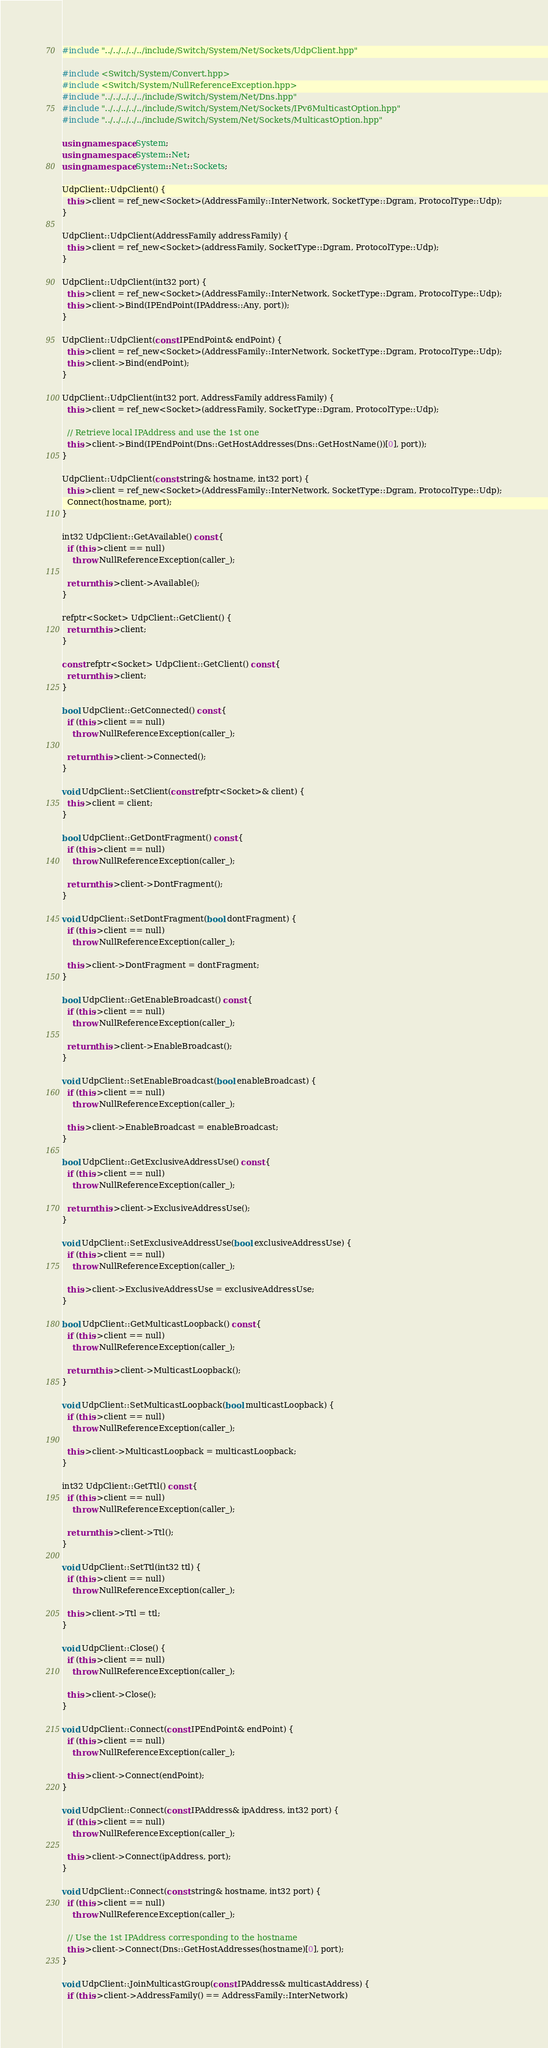Convert code to text. <code><loc_0><loc_0><loc_500><loc_500><_C++_>#include "../../../../../include/Switch/System/Net/Sockets/UdpClient.hpp"

#include <Switch/System/Convert.hpp>
#include <Switch/System/NullReferenceException.hpp>
#include "../../../../../include/Switch/System/Net/Dns.hpp"
#include "../../../../../include/Switch/System/Net/Sockets/IPv6MulticastOption.hpp"
#include "../../../../../include/Switch/System/Net/Sockets/MulticastOption.hpp"

using namespace System;
using namespace System::Net;
using namespace System::Net::Sockets;

UdpClient::UdpClient() {
  this->client = ref_new<Socket>(AddressFamily::InterNetwork, SocketType::Dgram, ProtocolType::Udp);
}

UdpClient::UdpClient(AddressFamily addressFamily) {
  this->client = ref_new<Socket>(addressFamily, SocketType::Dgram, ProtocolType::Udp);
}

UdpClient::UdpClient(int32 port) {
  this->client = ref_new<Socket>(AddressFamily::InterNetwork, SocketType::Dgram, ProtocolType::Udp);
  this->client->Bind(IPEndPoint(IPAddress::Any, port));
}

UdpClient::UdpClient(const IPEndPoint& endPoint) {
  this->client = ref_new<Socket>(AddressFamily::InterNetwork, SocketType::Dgram, ProtocolType::Udp);
  this->client->Bind(endPoint);
}

UdpClient::UdpClient(int32 port, AddressFamily addressFamily) {
  this->client = ref_new<Socket>(addressFamily, SocketType::Dgram, ProtocolType::Udp);

  // Retrieve local IPAddress and use the 1st one
  this->client->Bind(IPEndPoint(Dns::GetHostAddresses(Dns::GetHostName())[0], port));
}

UdpClient::UdpClient(const string& hostname, int32 port) {
  this->client = ref_new<Socket>(AddressFamily::InterNetwork, SocketType::Dgram, ProtocolType::Udp);
  Connect(hostname, port);
}

int32 UdpClient::GetAvailable() const {
  if (this->client == null)
    throw NullReferenceException(caller_);

  return this->client->Available();
}

refptr<Socket> UdpClient::GetClient() {
  return this->client;
}

const refptr<Socket> UdpClient::GetClient() const {
  return this->client;
}

bool UdpClient::GetConnected() const {
  if (this->client == null)
    throw NullReferenceException(caller_);

  return this->client->Connected();
}

void UdpClient::SetClient(const refptr<Socket>& client) {
  this->client = client;
}

bool UdpClient::GetDontFragment() const {
  if (this->client == null)
    throw NullReferenceException(caller_);

  return this->client->DontFragment();
}

void UdpClient::SetDontFragment(bool dontFragment) {
  if (this->client == null)
    throw NullReferenceException(caller_);

  this->client->DontFragment = dontFragment;
}

bool UdpClient::GetEnableBroadcast() const {
  if (this->client == null)
    throw NullReferenceException(caller_);

  return this->client->EnableBroadcast();
}

void UdpClient::SetEnableBroadcast(bool enableBroadcast) {
  if (this->client == null)
    throw NullReferenceException(caller_);

  this->client->EnableBroadcast = enableBroadcast;
}

bool UdpClient::GetExclusiveAddressUse() const {
  if (this->client == null)
    throw NullReferenceException(caller_);

  return this->client->ExclusiveAddressUse();
}

void UdpClient::SetExclusiveAddressUse(bool exclusiveAddressUse) {
  if (this->client == null)
    throw NullReferenceException(caller_);

  this->client->ExclusiveAddressUse = exclusiveAddressUse;
}

bool UdpClient::GetMulticastLoopback() const {
  if (this->client == null)
    throw NullReferenceException(caller_);

  return this->client->MulticastLoopback();
}

void UdpClient::SetMulticastLoopback(bool multicastLoopback) {
  if (this->client == null)
    throw NullReferenceException(caller_);

  this->client->MulticastLoopback = multicastLoopback;
}

int32 UdpClient::GetTtl() const {
  if (this->client == null)
    throw NullReferenceException(caller_);

  return this->client->Ttl();
}

void UdpClient::SetTtl(int32 ttl) {
  if (this->client == null)
    throw NullReferenceException(caller_);

  this->client->Ttl = ttl;
}

void UdpClient::Close() {
  if (this->client == null)
    throw NullReferenceException(caller_);

  this->client->Close();
}

void UdpClient::Connect(const IPEndPoint& endPoint) {
  if (this->client == null)
    throw NullReferenceException(caller_);

  this->client->Connect(endPoint);
}

void UdpClient::Connect(const IPAddress& ipAddress, int32 port) {
  if (this->client == null)
    throw NullReferenceException(caller_);

  this->client->Connect(ipAddress, port);
}

void UdpClient::Connect(const string& hostname, int32 port) {
  if (this->client == null)
    throw NullReferenceException(caller_);

  // Use the 1st IPAddress corresponding to the hostname
  this->client->Connect(Dns::GetHostAddresses(hostname)[0], port);
}

void UdpClient::JoinMulticastGroup(const IPAddress& multicastAddress) {
  if (this->client->AddressFamily() == AddressFamily::InterNetwork)</code> 